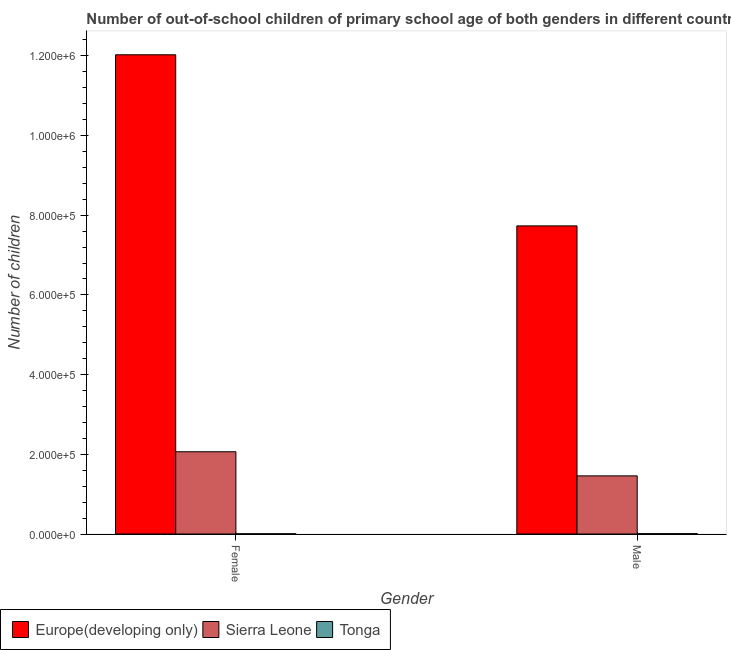How many different coloured bars are there?
Make the answer very short. 3. How many groups of bars are there?
Your answer should be very brief. 2. Are the number of bars on each tick of the X-axis equal?
Your answer should be very brief. Yes. How many bars are there on the 2nd tick from the right?
Offer a very short reply. 3. What is the label of the 2nd group of bars from the left?
Provide a short and direct response. Male. What is the number of male out-of-school students in Sierra Leone?
Give a very brief answer. 1.46e+05. Across all countries, what is the maximum number of female out-of-school students?
Ensure brevity in your answer.  1.20e+06. Across all countries, what is the minimum number of male out-of-school students?
Offer a terse response. 903. In which country was the number of male out-of-school students maximum?
Offer a terse response. Europe(developing only). In which country was the number of female out-of-school students minimum?
Offer a terse response. Tonga. What is the total number of female out-of-school students in the graph?
Make the answer very short. 1.41e+06. What is the difference between the number of female out-of-school students in Europe(developing only) and that in Sierra Leone?
Offer a terse response. 9.96e+05. What is the difference between the number of male out-of-school students in Sierra Leone and the number of female out-of-school students in Europe(developing only)?
Your answer should be very brief. -1.06e+06. What is the average number of female out-of-school students per country?
Keep it short and to the point. 4.70e+05. What is the difference between the number of male out-of-school students and number of female out-of-school students in Europe(developing only)?
Your answer should be compact. -4.29e+05. What is the ratio of the number of male out-of-school students in Tonga to that in Sierra Leone?
Your response must be concise. 0.01. What does the 2nd bar from the left in Male represents?
Your answer should be compact. Sierra Leone. What does the 1st bar from the right in Male represents?
Provide a short and direct response. Tonga. How many bars are there?
Offer a terse response. 6. How many countries are there in the graph?
Offer a very short reply. 3. What is the difference between two consecutive major ticks on the Y-axis?
Ensure brevity in your answer.  2.00e+05. Are the values on the major ticks of Y-axis written in scientific E-notation?
Your answer should be very brief. Yes. What is the title of the graph?
Ensure brevity in your answer.  Number of out-of-school children of primary school age of both genders in different countries. Does "Faeroe Islands" appear as one of the legend labels in the graph?
Your response must be concise. No. What is the label or title of the Y-axis?
Your answer should be very brief. Number of children. What is the Number of children in Europe(developing only) in Female?
Your answer should be compact. 1.20e+06. What is the Number of children in Sierra Leone in Female?
Keep it short and to the point. 2.06e+05. What is the Number of children in Tonga in Female?
Make the answer very short. 478. What is the Number of children in Europe(developing only) in Male?
Your answer should be compact. 7.73e+05. What is the Number of children of Sierra Leone in Male?
Provide a succinct answer. 1.46e+05. What is the Number of children of Tonga in Male?
Your answer should be compact. 903. Across all Gender, what is the maximum Number of children of Europe(developing only)?
Offer a very short reply. 1.20e+06. Across all Gender, what is the maximum Number of children of Sierra Leone?
Offer a terse response. 2.06e+05. Across all Gender, what is the maximum Number of children in Tonga?
Your answer should be very brief. 903. Across all Gender, what is the minimum Number of children of Europe(developing only)?
Make the answer very short. 7.73e+05. Across all Gender, what is the minimum Number of children in Sierra Leone?
Ensure brevity in your answer.  1.46e+05. Across all Gender, what is the minimum Number of children of Tonga?
Ensure brevity in your answer.  478. What is the total Number of children of Europe(developing only) in the graph?
Ensure brevity in your answer.  1.98e+06. What is the total Number of children in Sierra Leone in the graph?
Give a very brief answer. 3.52e+05. What is the total Number of children in Tonga in the graph?
Give a very brief answer. 1381. What is the difference between the Number of children in Europe(developing only) in Female and that in Male?
Provide a succinct answer. 4.29e+05. What is the difference between the Number of children of Sierra Leone in Female and that in Male?
Offer a terse response. 6.05e+04. What is the difference between the Number of children in Tonga in Female and that in Male?
Give a very brief answer. -425. What is the difference between the Number of children in Europe(developing only) in Female and the Number of children in Sierra Leone in Male?
Your answer should be very brief. 1.06e+06. What is the difference between the Number of children in Europe(developing only) in Female and the Number of children in Tonga in Male?
Offer a very short reply. 1.20e+06. What is the difference between the Number of children of Sierra Leone in Female and the Number of children of Tonga in Male?
Offer a very short reply. 2.06e+05. What is the average Number of children in Europe(developing only) per Gender?
Make the answer very short. 9.88e+05. What is the average Number of children in Sierra Leone per Gender?
Your answer should be very brief. 1.76e+05. What is the average Number of children of Tonga per Gender?
Offer a very short reply. 690.5. What is the difference between the Number of children in Europe(developing only) and Number of children in Sierra Leone in Female?
Provide a succinct answer. 9.96e+05. What is the difference between the Number of children in Europe(developing only) and Number of children in Tonga in Female?
Keep it short and to the point. 1.20e+06. What is the difference between the Number of children of Sierra Leone and Number of children of Tonga in Female?
Give a very brief answer. 2.06e+05. What is the difference between the Number of children of Europe(developing only) and Number of children of Sierra Leone in Male?
Ensure brevity in your answer.  6.27e+05. What is the difference between the Number of children in Europe(developing only) and Number of children in Tonga in Male?
Make the answer very short. 7.72e+05. What is the difference between the Number of children in Sierra Leone and Number of children in Tonga in Male?
Provide a succinct answer. 1.45e+05. What is the ratio of the Number of children in Europe(developing only) in Female to that in Male?
Offer a terse response. 1.56. What is the ratio of the Number of children in Sierra Leone in Female to that in Male?
Your answer should be compact. 1.41. What is the ratio of the Number of children of Tonga in Female to that in Male?
Offer a very short reply. 0.53. What is the difference between the highest and the second highest Number of children of Europe(developing only)?
Offer a very short reply. 4.29e+05. What is the difference between the highest and the second highest Number of children in Sierra Leone?
Your answer should be very brief. 6.05e+04. What is the difference between the highest and the second highest Number of children in Tonga?
Your response must be concise. 425. What is the difference between the highest and the lowest Number of children in Europe(developing only)?
Your response must be concise. 4.29e+05. What is the difference between the highest and the lowest Number of children in Sierra Leone?
Your answer should be compact. 6.05e+04. What is the difference between the highest and the lowest Number of children in Tonga?
Ensure brevity in your answer.  425. 